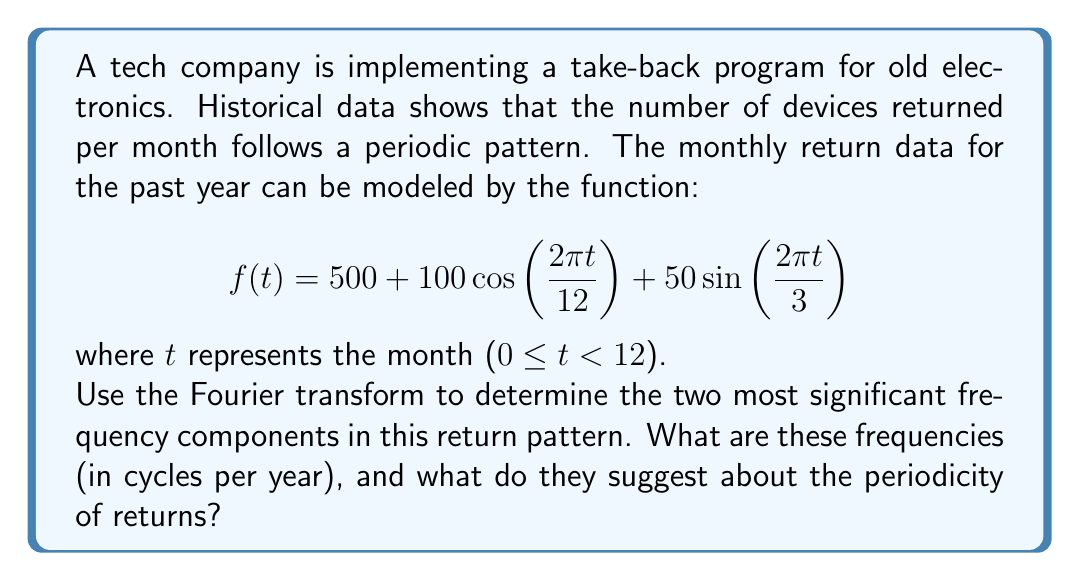Give your solution to this math problem. To solve this problem, we need to apply the Fourier transform to the given function and analyze its frequency components. Let's break it down step-by-step:

1) The given function is already expressed as a sum of sinusoidal functions, which makes our analysis easier. We have:

   $$f(t) = 500 + 100\cos\left(\frac{2\pi t}{12}\right) + 50\sin\left(\frac{2\pi t}{3}\right)$$

2) Let's identify the frequency components:

   a) The constant term 500 represents the DC component (frequency = 0 cycles/year).
   
   b) For the cosine term: $\cos\left(\frac{2\pi t}{12}\right)$
      Frequency = $\frac{1}{12}$ cycles/month = 1 cycle/year
   
   c) For the sine term: $\sin\left(\frac{2\pi t}{3}\right)$
      Frequency = $\frac{1}{3}$ cycles/month = 4 cycles/year

3) Now, let's look at the amplitudes of these components:

   a) DC component: 500
   b) 1 cycle/year component: 100
   c) 4 cycles/year component: 50

4) The two most significant frequency components (excluding the DC component) are:
   - 1 cycle/year with amplitude 100
   - 4 cycles/year with amplitude 50

5) Interpretation:
   - The 1 cycle/year component suggests an annual pattern in returns, possibly due to yearly product releases or holiday seasons.
   - The 4 cycles/year component indicates a quarterly pattern, which could be related to seasonal changes or quarterly business cycles.
Answer: The two most significant frequency components are 1 cycle/year and 4 cycles/year. This suggests that the return pattern has strong annual and quarterly periodicities. 